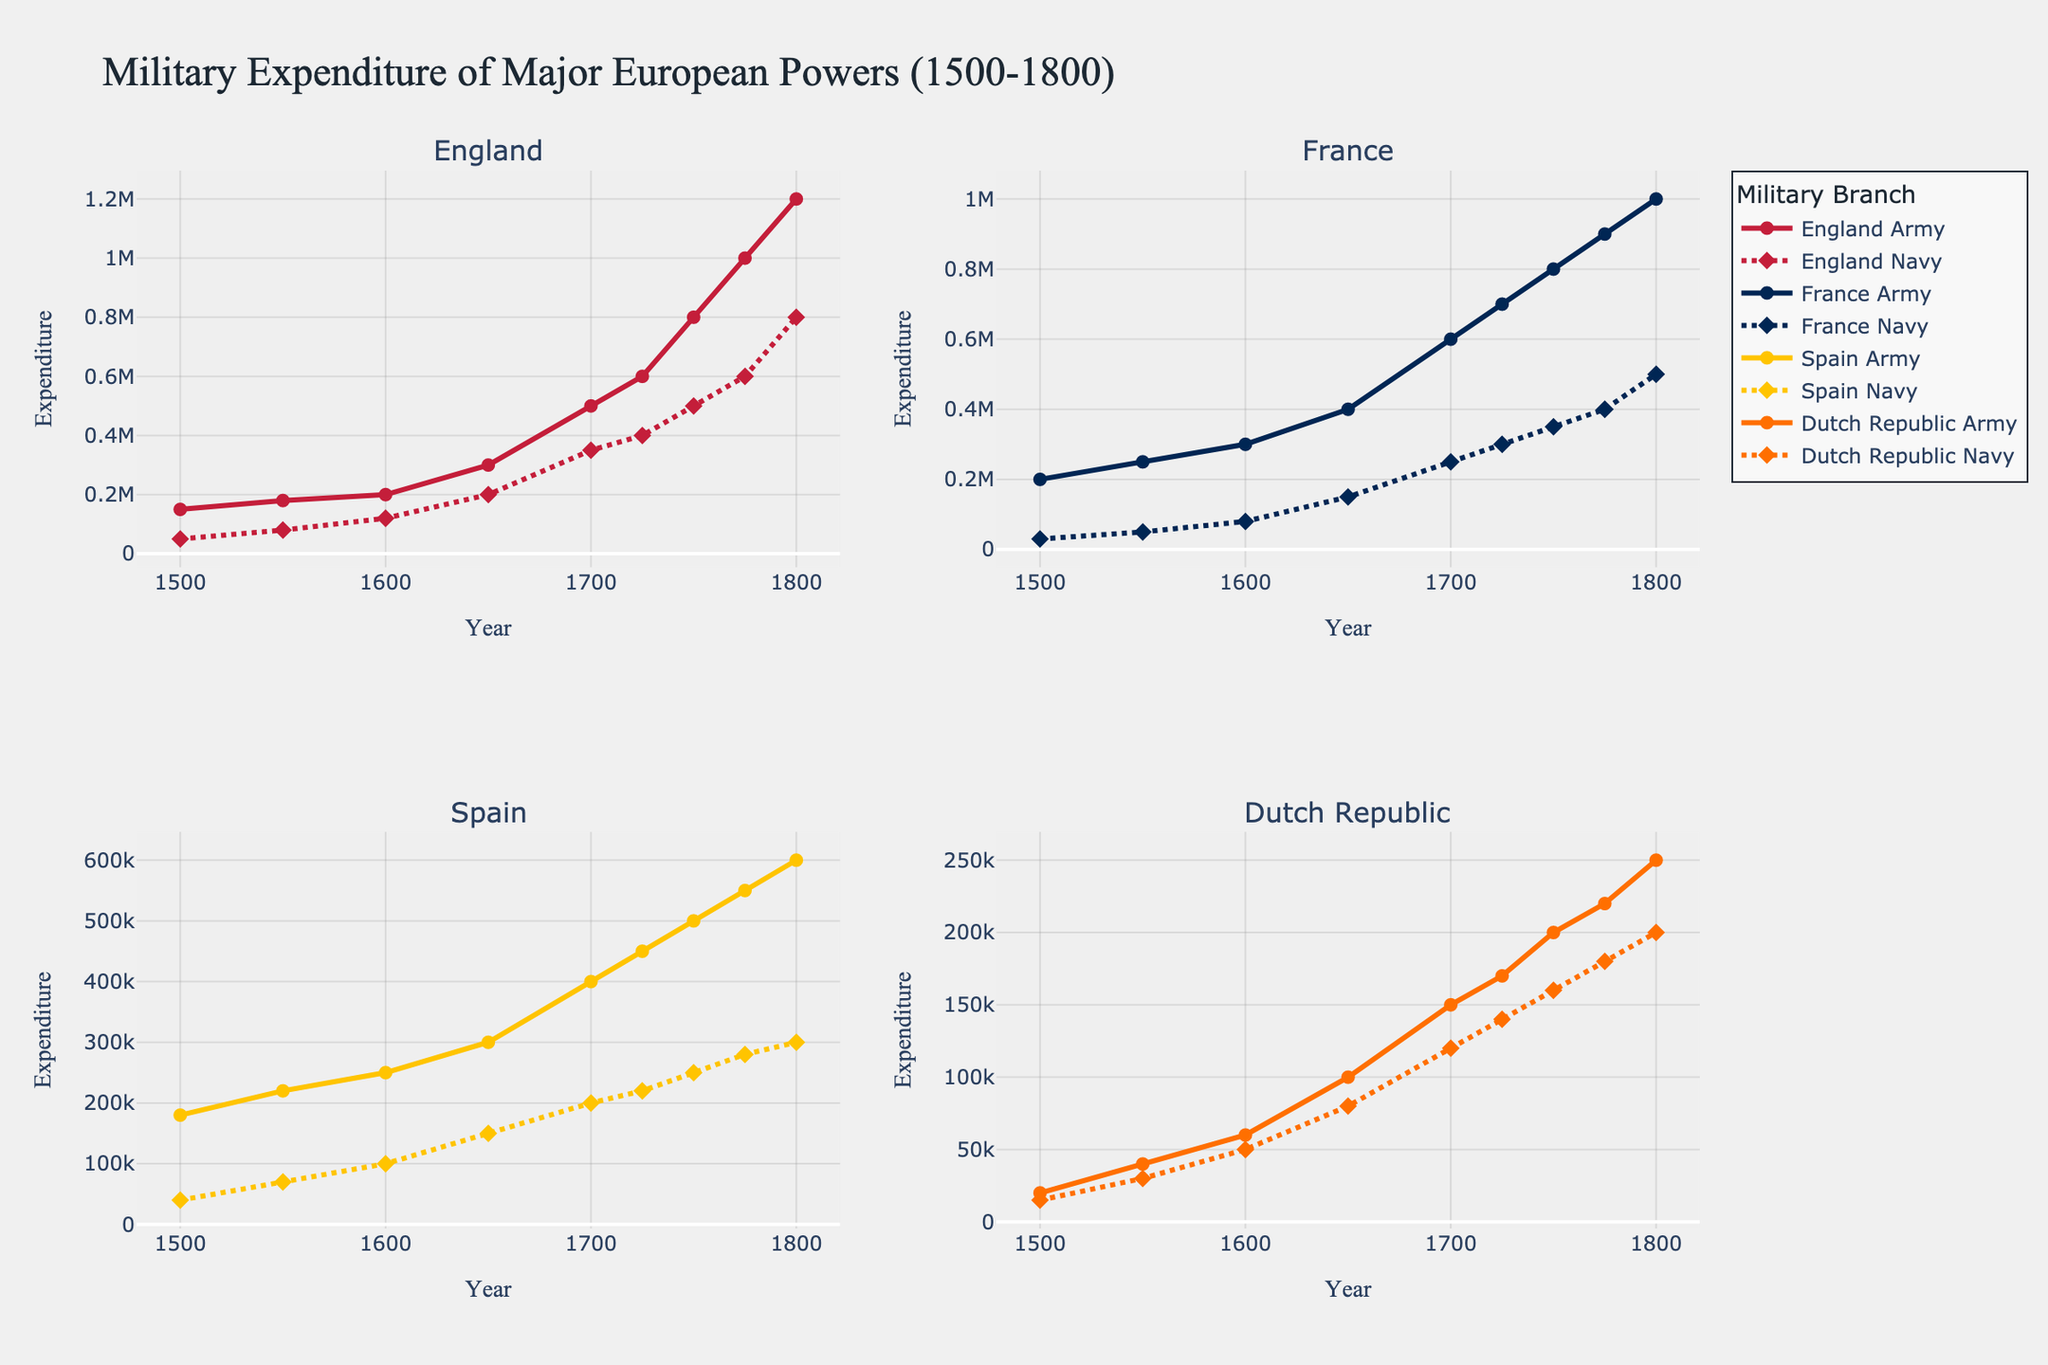Which country shows the highest army expenditure in 1800? To find the answer, locate the 1800 marker on the x-axis and compare the heights of the lines representing army expenditures for all countries. The line for England Army reaches the highest point.
Answer: England Which country's navy expenditure increased the most from 1500 to 1800? Find the difference between navy expenditures in 1500 and 1800 for each country and compare them. England's navy expenditure increased the most, from 50,000 to 800,000, showing a difference of 750,000.
Answer: England Add the army and navy expenditures for France in 1700. What is the total? Look at the values for France Army and France Navy in 1700, which are 600,000 and 250,000 respectively. The total is 600,000 + 250,000 = 850,000.
Answer: 850,000 How does the Spanish Navy expenditure in 1650 compare to the Dutch Republic's Navy expenditure in the same year? Check the navy expenditure values for both Spain and Dutch Republic in 1650. Spain's navy expenditure is 150,000, while the Dutch Republic's is 80,000. Spain's navy expenditure is greater.
Answer: Spain's is greater Which country had the least army expenditure in 1725? Locate the 1725 marker on the x-axis and compare the heights of the lines representing army expenditures. The Dutch Republic Army has the lowest expenditure at that point.
Answer: Dutch Republic Find the average of England's army expenditure over the entire period (1500 to 1800). Sum all values for England Army expenditures from 1500 to 1800 and divide by the number of data points (9). Sum is 150,000 + 180,000 + 200,000 + 300,000 + 500,000 + 600,000 + 800,000 + 1,000,000 + 1,200,000 = 4,930,000. The average is 4,930,000 / 9 = 547,778 (approx).
Answer: 547,778 Which country had the greatest difference between army and navy expenditure in 1775? For each country, subtract the navy expenditure from the army expenditure for 1775 and find the greatest difference. England Army (1,000,000) - Navy (600,000) = 400,000, France Army (900,000) - Navy (400,000) = 500,000, Spain Army (550,000) - Navy (280,000) = 270,000, Dutch Republic Army (220,000) - Navy (180,000) = 40,000. The greatest difference is for France, 500,000.
Answer: France Describe the trend of England's navy expenditure from 1500 to 1800. Observe the changes in the heights of the England Navy line from 1500 to 1800. The expenditure shows a continuous increase from 50,000 in 1500 to 800,000 in 1800 without any significant drops.
Answer: Continuously increasing Between 1600 and 1700, which country's army expenditure increased the fastest? Calculate the increase in army expenditure from 1600 to 1700 for each country. England (300,000), France (300,000), Spain (150,000), Dutch Republic (90,000). The fastest increase occurred for France.
Answer: France What is the overall trend in military spending among major European powers from 1500 to 1800? Observe the overall height of the lines (both army and navy) for all countries from 1500 to 1800. Military expenditures for all four countries show an increasing trend over the given period.
Answer: Increasing 